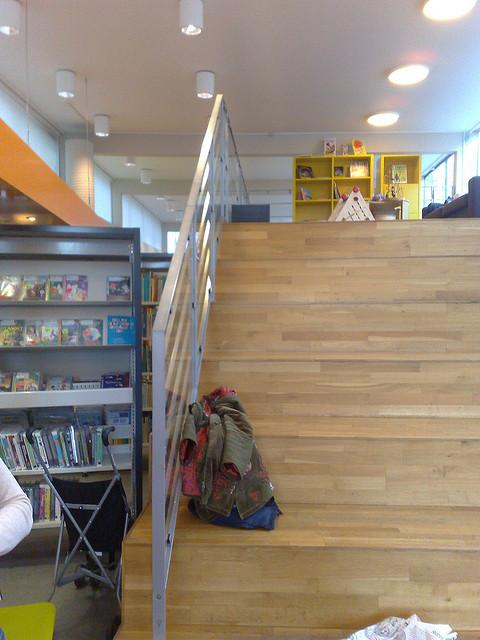What is next to the wooden steps? clothes 